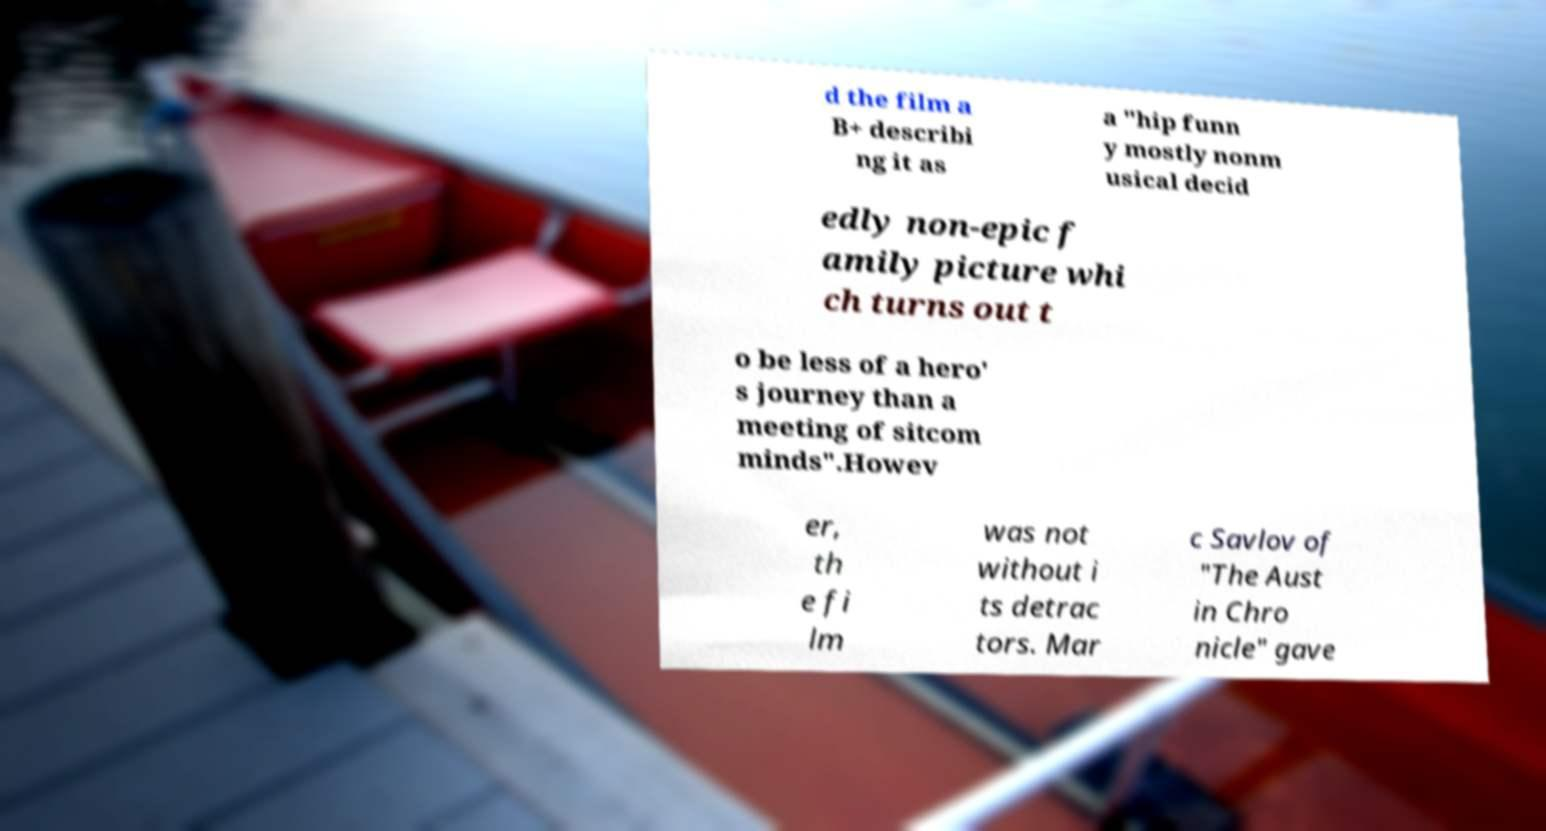Please read and relay the text visible in this image. What does it say? d the film a B+ describi ng it as a "hip funn y mostly nonm usical decid edly non-epic f amily picture whi ch turns out t o be less of a hero' s journey than a meeting of sitcom minds".Howev er, th e fi lm was not without i ts detrac tors. Mar c Savlov of "The Aust in Chro nicle" gave 